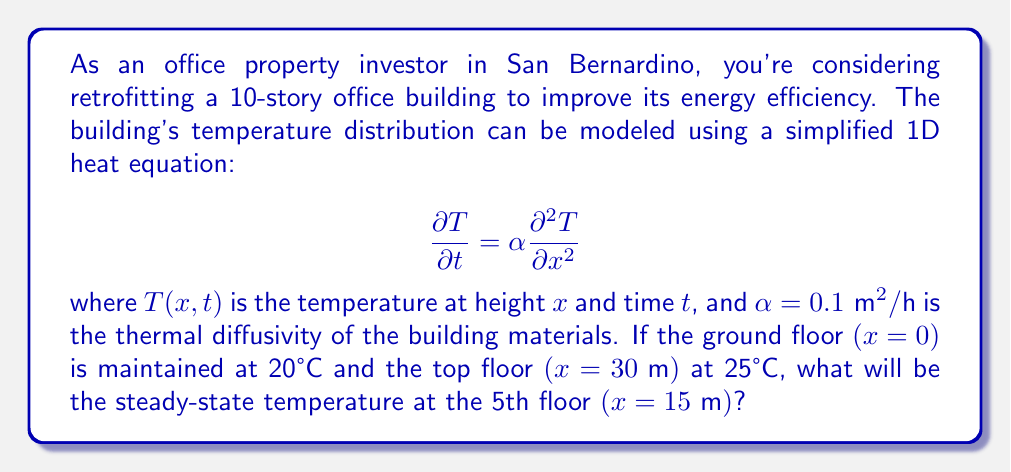What is the answer to this math problem? To solve this problem, we need to find the steady-state solution of the heat equation. In steady-state, the temperature doesn't change with time, so $\frac{\partial T}{\partial t} = 0$. This reduces our equation to:

$$0 = \alpha \frac{\partial^2 T}{\partial x^2}$$

Integrating twice with respect to $x$, we get:

$$T(x) = Ax + B$$

where $A$ and $B$ are constants we need to determine using the boundary conditions.

Boundary conditions:
1. At $x=0$, $T(0) = 20°C$
2. At $x=30\text{ m}$, $T(30) = 25°C$

Applying these conditions:

1. $T(0) = B = 20°C$
2. $T(30) = 30A + 20 = 25°C$

Solving for $A$:
$$A = \frac{25-20}{30} = \frac{1}{6} °C/\text{m}$$

Therefore, our steady-state temperature distribution is:

$$T(x) = \frac{1}{6}x + 20$$

To find the temperature at the 5th floor $(x=15\text{ m})$, we substitute $x=15$ into this equation:

$$T(15) = \frac{1}{6} \cdot 15 + 20 = 2.5 + 20 = 22.5°C$$
Answer: The steady-state temperature at the 5th floor $(x=15\text{ m})$ will be 22.5°C. 